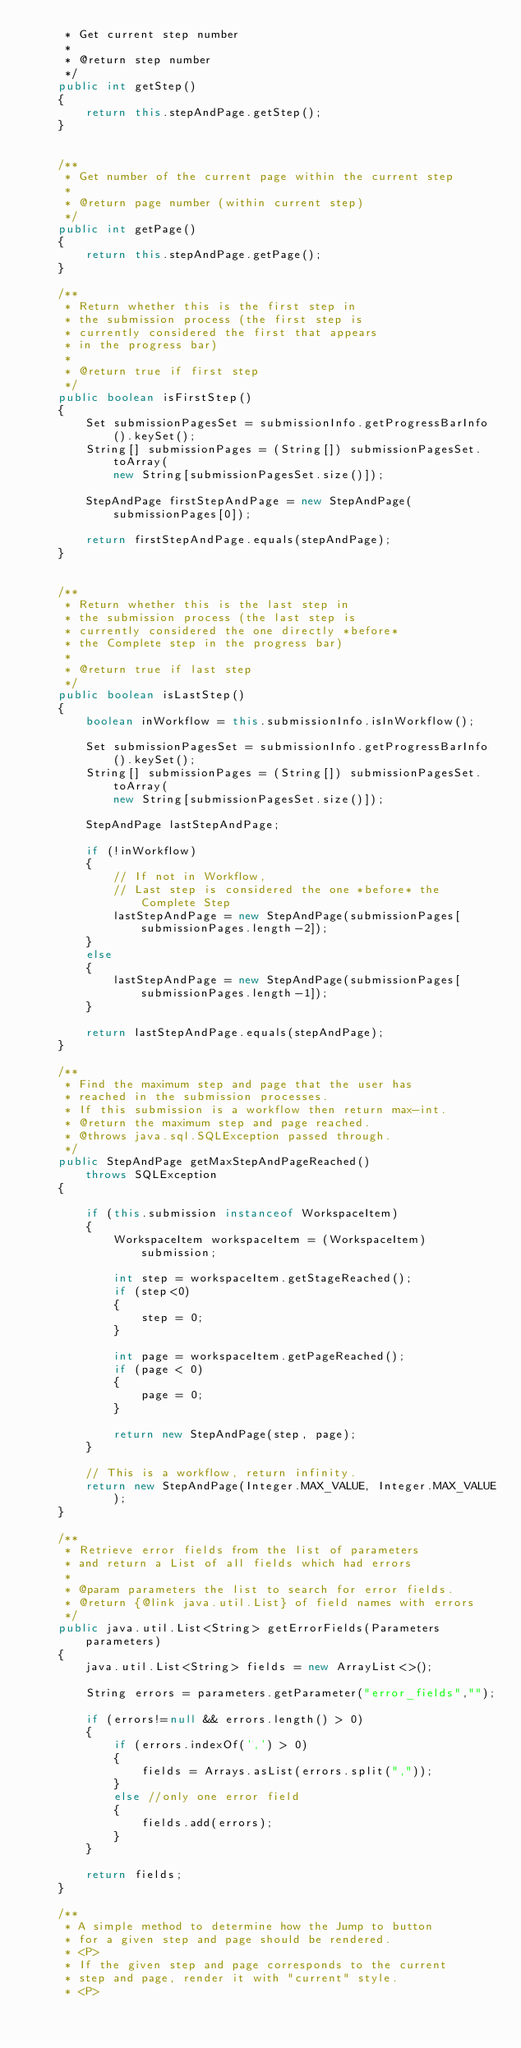Convert code to text. <code><loc_0><loc_0><loc_500><loc_500><_Java_>     * Get current step number
     *
     * @return step number
     */
    public int getStep()
    {
        return this.stepAndPage.getStep();
    }


    /**
     * Get number of the current page within the current step
     *
     * @return page number (within current step)
     */
    public int getPage()
    {
        return this.stepAndPage.getPage();
    }

    /**
     * Return whether this is the first step in
     * the submission process (the first step is
     * currently considered the first that appears
     * in the progress bar)
     *
     * @return true if first step
     */
    public boolean isFirstStep()
    {
        Set submissionPagesSet = submissionInfo.getProgressBarInfo().keySet();
        String[] submissionPages = (String[]) submissionPagesSet.toArray(
            new String[submissionPagesSet.size()]);

        StepAndPage firstStepAndPage = new StepAndPage(submissionPages[0]);

        return firstStepAndPage.equals(stepAndPage);
    }


    /**
     * Return whether this is the last step in
     * the submission process (the last step is
     * currently considered the one directly *before*
     * the Complete step in the progress bar)
     *
     * @return true if last step
     */
    public boolean isLastStep()
    {
        boolean inWorkflow = this.submissionInfo.isInWorkflow();

        Set submissionPagesSet = submissionInfo.getProgressBarInfo().keySet();
        String[] submissionPages = (String[]) submissionPagesSet.toArray(
            new String[submissionPagesSet.size()]);

        StepAndPage lastStepAndPage;

        if (!inWorkflow)
        {
            // If not in Workflow,
            // Last step is considered the one *before* the Complete Step
            lastStepAndPage = new StepAndPage(submissionPages[submissionPages.length-2]);
        }
        else
        {
            lastStepAndPage = new StepAndPage(submissionPages[submissionPages.length-1]);
        }

        return lastStepAndPage.equals(stepAndPage);
    }

    /**
     * Find the maximum step and page that the user has
     * reached in the submission processes. 
     * If this submission is a workflow then return max-int.
     * @return the maximum step and page reached.
     * @throws java.sql.SQLException passed through.
     */
    public StepAndPage getMaxStepAndPageReached()
        throws SQLException
    {

        if (this.submission instanceof WorkspaceItem)
        {
            WorkspaceItem workspaceItem = (WorkspaceItem) submission;

            int step = workspaceItem.getStageReached();
            if (step<0)
            {
                step = 0;
            }

            int page = workspaceItem.getPageReached();
            if (page < 0)
            {
                page = 0;
            }

            return new StepAndPage(step, page);
        }

        // This is a workflow, return infinity.
        return new StepAndPage(Integer.MAX_VALUE, Integer.MAX_VALUE);
    }

    /**
     * Retrieve error fields from the list of parameters
     * and return a List of all fields which had errors
     *
     * @param parameters the list to search for error fields.
     * @return {@link java.util.List} of field names with errors
     */
    public java.util.List<String> getErrorFields(Parameters parameters)
    {
        java.util.List<String> fields = new ArrayList<>();

        String errors = parameters.getParameter("error_fields","");

        if (errors!=null && errors.length() > 0)
        {
            if (errors.indexOf(',') > 0)
            {
                fields = Arrays.asList(errors.split(","));
            }
            else //only one error field
            {
                fields.add(errors);
            }
        }

        return fields;
    }

    /**
     * A simple method to determine how the Jump to button
     * for a given step and page should be rendered.
     * <P>
     * If the given step and page corresponds to the current
     * step and page, render it with "current" style.
     * <P></code> 